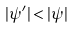Convert formula to latex. <formula><loc_0><loc_0><loc_500><loc_500>| \psi ^ { \prime } | < | \psi |</formula> 